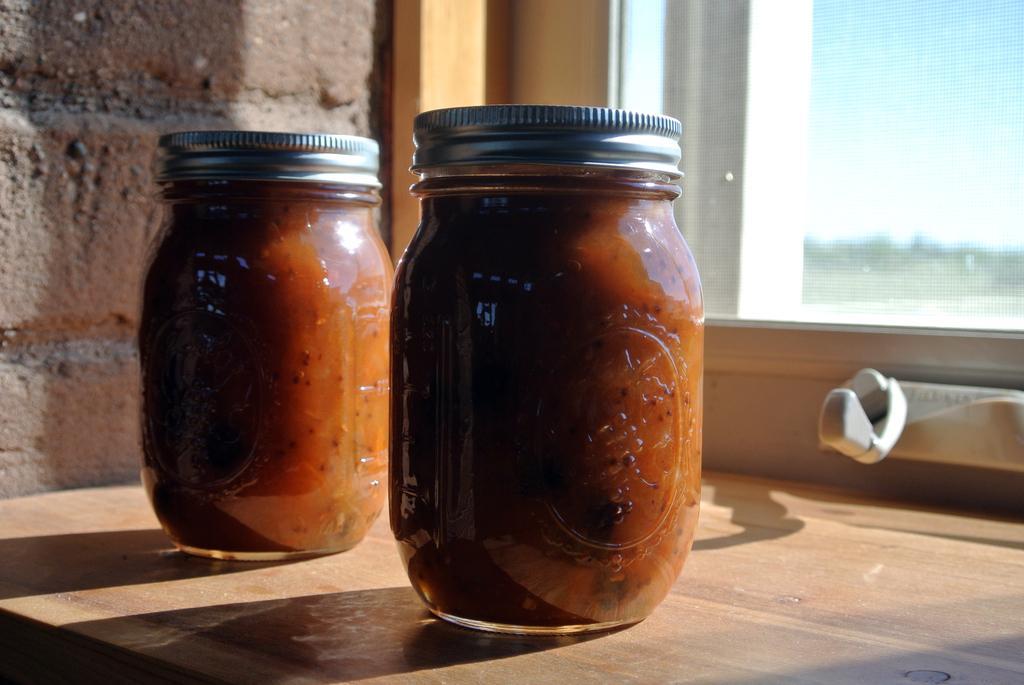Could you give a brief overview of what you see in this image? In this image we can see jars placed on the table. In the background there is a wall and a window. 